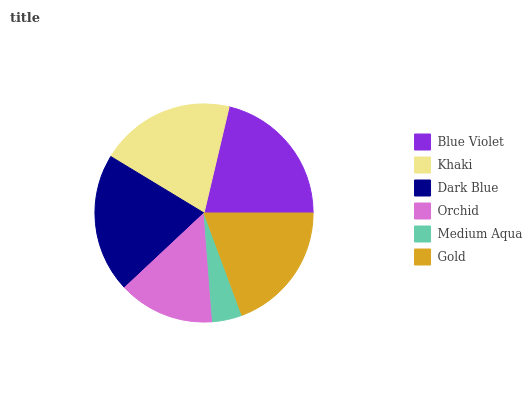Is Medium Aqua the minimum?
Answer yes or no. Yes. Is Blue Violet the maximum?
Answer yes or no. Yes. Is Khaki the minimum?
Answer yes or no. No. Is Khaki the maximum?
Answer yes or no. No. Is Blue Violet greater than Khaki?
Answer yes or no. Yes. Is Khaki less than Blue Violet?
Answer yes or no. Yes. Is Khaki greater than Blue Violet?
Answer yes or no. No. Is Blue Violet less than Khaki?
Answer yes or no. No. Is Khaki the high median?
Answer yes or no. Yes. Is Gold the low median?
Answer yes or no. Yes. Is Orchid the high median?
Answer yes or no. No. Is Khaki the low median?
Answer yes or no. No. 